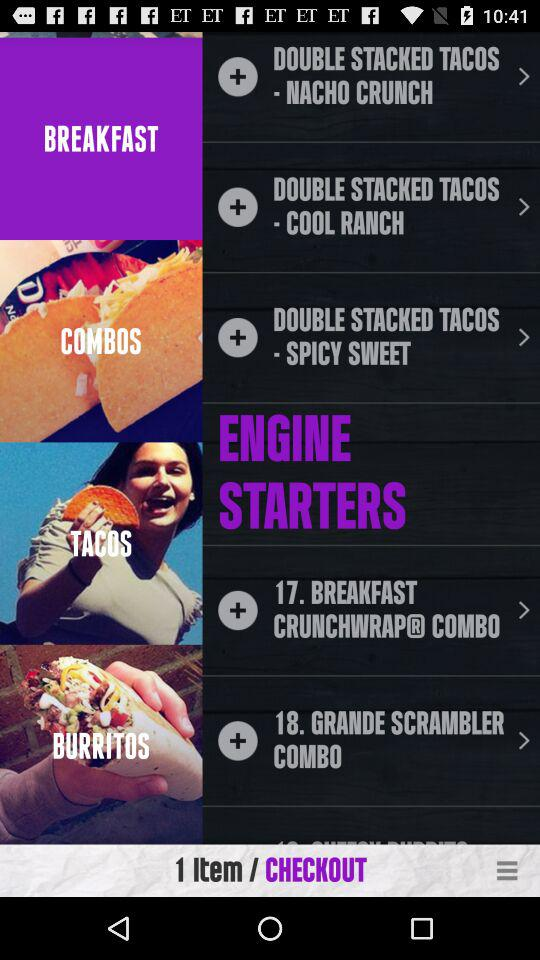How many items are in the cart?
Answer the question using a single word or phrase. 1 